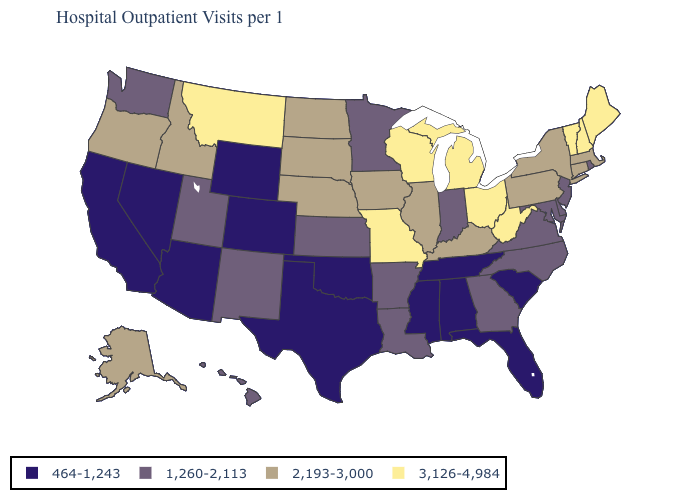Name the states that have a value in the range 2,193-3,000?
Be succinct. Alaska, Connecticut, Idaho, Illinois, Iowa, Kentucky, Massachusetts, Nebraska, New York, North Dakota, Oregon, Pennsylvania, South Dakota. What is the value of Washington?
Write a very short answer. 1,260-2,113. What is the value of Oregon?
Keep it brief. 2,193-3,000. Name the states that have a value in the range 2,193-3,000?
Be succinct. Alaska, Connecticut, Idaho, Illinois, Iowa, Kentucky, Massachusetts, Nebraska, New York, North Dakota, Oregon, Pennsylvania, South Dakota. Name the states that have a value in the range 1,260-2,113?
Keep it brief. Arkansas, Delaware, Georgia, Hawaii, Indiana, Kansas, Louisiana, Maryland, Minnesota, New Jersey, New Mexico, North Carolina, Rhode Island, Utah, Virginia, Washington. What is the lowest value in states that border Maryland?
Answer briefly. 1,260-2,113. Does Indiana have the lowest value in the MidWest?
Short answer required. Yes. What is the value of Texas?
Short answer required. 464-1,243. What is the value of South Carolina?
Short answer required. 464-1,243. Which states have the highest value in the USA?
Be succinct. Maine, Michigan, Missouri, Montana, New Hampshire, Ohio, Vermont, West Virginia, Wisconsin. What is the highest value in the West ?
Quick response, please. 3,126-4,984. Does Alabama have the lowest value in the South?
Short answer required. Yes. What is the value of Vermont?
Keep it brief. 3,126-4,984. Name the states that have a value in the range 464-1,243?
Answer briefly. Alabama, Arizona, California, Colorado, Florida, Mississippi, Nevada, Oklahoma, South Carolina, Tennessee, Texas, Wyoming. Name the states that have a value in the range 2,193-3,000?
Give a very brief answer. Alaska, Connecticut, Idaho, Illinois, Iowa, Kentucky, Massachusetts, Nebraska, New York, North Dakota, Oregon, Pennsylvania, South Dakota. 